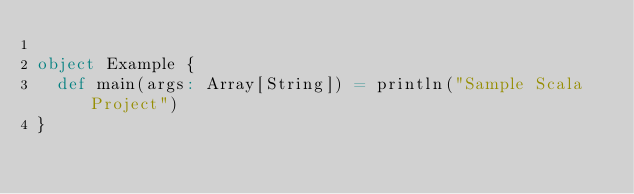<code> <loc_0><loc_0><loc_500><loc_500><_Scala_>
object Example {
  def main(args: Array[String]) = println("Sample Scala Project")
}</code> 